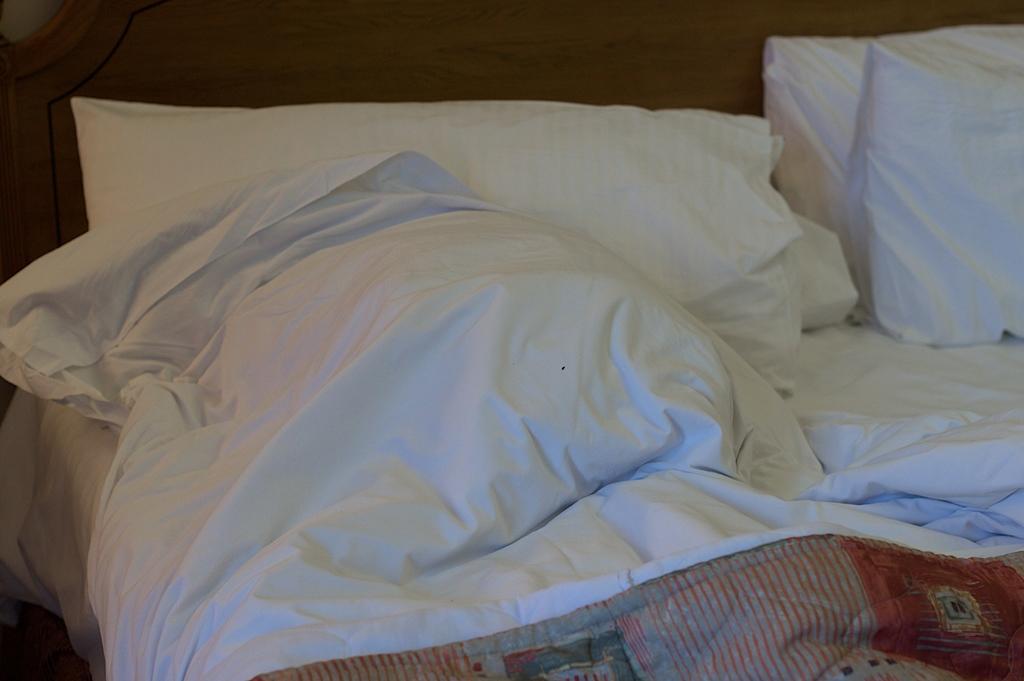Can you describe this image briefly? In the image we can see there is a bed which is in white colour on which there are pillows and a blanket. 